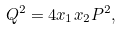Convert formula to latex. <formula><loc_0><loc_0><loc_500><loc_500>Q ^ { 2 } = 4 x _ { 1 } x _ { 2 } P ^ { 2 } ,</formula> 